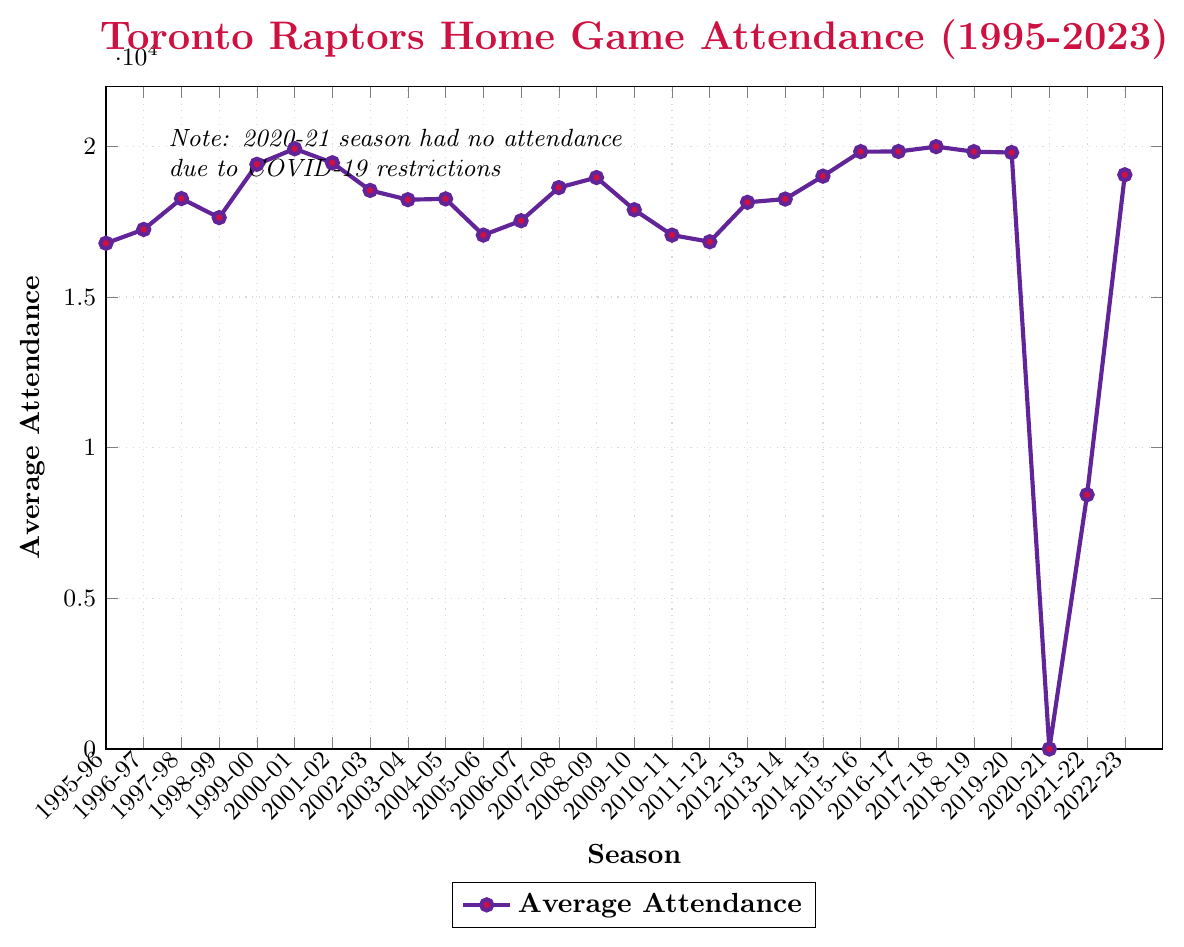What was the average attendance for the Toronto Raptors' home games during their inaugural season? The chart shows the average attendance for multiple seasons. For the 1995-96 season (their inaugural season), locate the corresponding point and read the associated attendance value.
Answer: 16,785 During which season did the Toronto Raptors have the highest average attendance, and what was that attendance? Identify the peak point on the line chart and find the corresponding season label and numerical value.
Answer: 2017-18, 19,991 How did the average attendance change from the 1998-99 season to the 1999-00 season? Locate the points for the 1998-99 and 1999-00 seasons. Subtract the 1998-99 value from the 1999-00 value to find the difference.
Answer: Increase of 1,769 Which seasons had an average attendance above 19,000? Identify the points where the attendance value exceeds 19,000 and list the corresponding seasons.
Answer: 1999-00, 2000-01, 2015-16, 2016-17, 2017-18, 2018-19, 2022-23 What was the impact of COVID-19 on the average attendance for the 2020-21 season? Observe the data point for the 2020-21 season, which is explicitly mentioned as zero due to COVID-19 restrictions in the chart note.
Answer: 0 (no attendance) Compare the average attendance for the 2007-08 and 2009-10 seasons. Which season had higher attendance and by how much? Locate the points for both seasons and compare the values. Subtract to find the difference.
Answer: 2007-08 by 735 How did the average attendance trend change from the 2005-06 season to the 2006-07 season? Identify the points for both seasons and compare the values. Determine if it increased or decreased.
Answer: Increased by 476 What is the average of the average attendances for the seasons from 2015-16 to 2018-19? Sum the average attendances for the 2015-16, 2016-17, 2017-18, and 2018-19 seasons. Divide by 4 to find the average.
Answer: 19,868 Which is the only season where the average attendance was below 10,000 other than the 2020-21 season? Identify points below 10,000 and cross-check with the chart note.
Answer: 2021-22 What was the average attendance for home games during the 2000-01 Vince Carter era? Locate the data point for the 2000-01 season and read the corresponding attendance value.
Answer: 19,921 